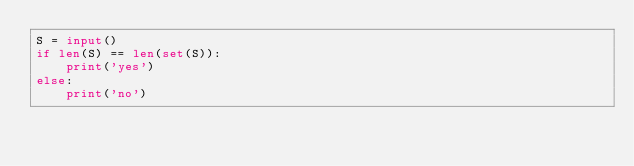Convert code to text. <code><loc_0><loc_0><loc_500><loc_500><_Python_>S = input()
if len(S) == len(set(S)):
    print('yes')
else:
    print('no')</code> 